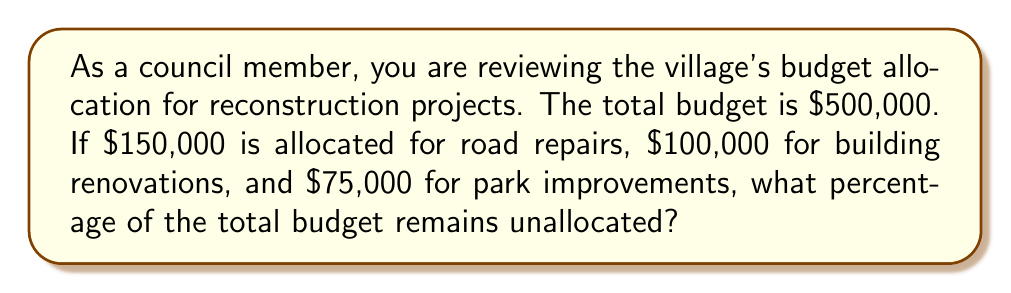Help me with this question. To solve this problem, we'll follow these steps:

1. Calculate the total allocated amount:
   $150,000 + $100,000 + $75,000 = $325,000

2. Calculate the remaining unallocated amount:
   $500,000 - $325,000 = $175,000

3. Calculate the percentage of the total budget that remains unallocated:
   Let $x$ be the percentage we're looking for.
   
   $$\frac{175,000}{500,000} = \frac{x}{100}$$

4. Solve for $x$:
   $$x = \frac{175,000 \times 100}{500,000} = 35$$

Therefore, 35% of the total budget remains unallocated.
Answer: 35% 